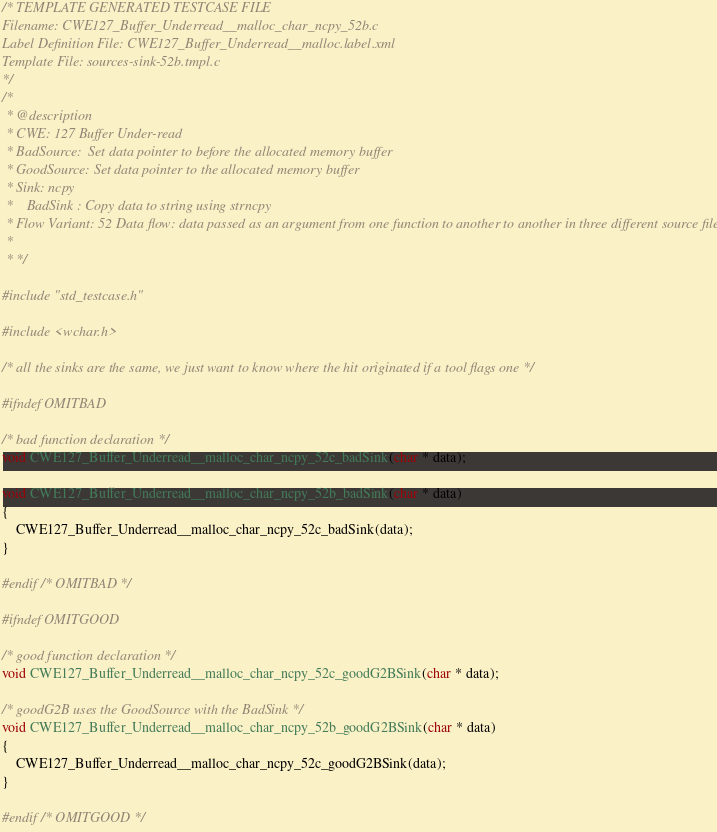<code> <loc_0><loc_0><loc_500><loc_500><_C_>/* TEMPLATE GENERATED TESTCASE FILE
Filename: CWE127_Buffer_Underread__malloc_char_ncpy_52b.c
Label Definition File: CWE127_Buffer_Underread__malloc.label.xml
Template File: sources-sink-52b.tmpl.c
*/
/*
 * @description
 * CWE: 127 Buffer Under-read
 * BadSource:  Set data pointer to before the allocated memory buffer
 * GoodSource: Set data pointer to the allocated memory buffer
 * Sink: ncpy
 *    BadSink : Copy data to string using strncpy
 * Flow Variant: 52 Data flow: data passed as an argument from one function to another to another in three different source files
 *
 * */

#include "std_testcase.h"

#include <wchar.h>

/* all the sinks are the same, we just want to know where the hit originated if a tool flags one */

#ifndef OMITBAD

/* bad function declaration */
void CWE127_Buffer_Underread__malloc_char_ncpy_52c_badSink(char * data);

void CWE127_Buffer_Underread__malloc_char_ncpy_52b_badSink(char * data)
{
    CWE127_Buffer_Underread__malloc_char_ncpy_52c_badSink(data);
}

#endif /* OMITBAD */

#ifndef OMITGOOD

/* good function declaration */
void CWE127_Buffer_Underread__malloc_char_ncpy_52c_goodG2BSink(char * data);

/* goodG2B uses the GoodSource with the BadSink */
void CWE127_Buffer_Underread__malloc_char_ncpy_52b_goodG2BSink(char * data)
{
    CWE127_Buffer_Underread__malloc_char_ncpy_52c_goodG2BSink(data);
}

#endif /* OMITGOOD */
</code> 